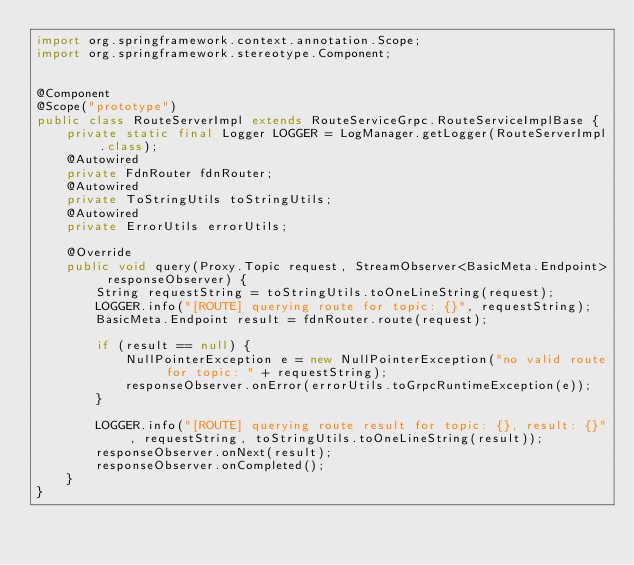<code> <loc_0><loc_0><loc_500><loc_500><_Java_>import org.springframework.context.annotation.Scope;
import org.springframework.stereotype.Component;


@Component
@Scope("prototype")
public class RouteServerImpl extends RouteServiceGrpc.RouteServiceImplBase {
    private static final Logger LOGGER = LogManager.getLogger(RouteServerImpl.class);
    @Autowired
    private FdnRouter fdnRouter;
    @Autowired
    private ToStringUtils toStringUtils;
    @Autowired
    private ErrorUtils errorUtils;

    @Override
    public void query(Proxy.Topic request, StreamObserver<BasicMeta.Endpoint> responseObserver) {
        String requestString = toStringUtils.toOneLineString(request);
        LOGGER.info("[ROUTE] querying route for topic: {}", requestString);
        BasicMeta.Endpoint result = fdnRouter.route(request);

        if (result == null) {
            NullPointerException e = new NullPointerException("no valid route for topic: " + requestString);
            responseObserver.onError(errorUtils.toGrpcRuntimeException(e));
        }

        LOGGER.info("[ROUTE] querying route result for topic: {}, result: {}", requestString, toStringUtils.toOneLineString(result));
        responseObserver.onNext(result);
        responseObserver.onCompleted();
    }
}
</code> 